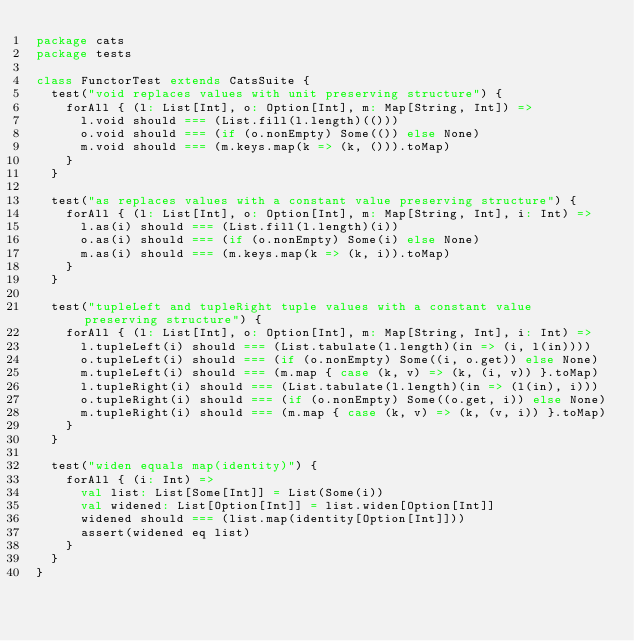Convert code to text. <code><loc_0><loc_0><loc_500><loc_500><_Scala_>package cats
package tests

class FunctorTest extends CatsSuite {
  test("void replaces values with unit preserving structure") {
    forAll { (l: List[Int], o: Option[Int], m: Map[String, Int]) =>
      l.void should === (List.fill(l.length)(()))
      o.void should === (if (o.nonEmpty) Some(()) else None)
      m.void should === (m.keys.map(k => (k, ())).toMap)
    }
  }

  test("as replaces values with a constant value preserving structure") {
    forAll { (l: List[Int], o: Option[Int], m: Map[String, Int], i: Int) =>
      l.as(i) should === (List.fill(l.length)(i))
      o.as(i) should === (if (o.nonEmpty) Some(i) else None)
      m.as(i) should === (m.keys.map(k => (k, i)).toMap)
    }
  }

  test("tupleLeft and tupleRight tuple values with a constant value preserving structure") {
    forAll { (l: List[Int], o: Option[Int], m: Map[String, Int], i: Int) =>
      l.tupleLeft(i) should === (List.tabulate(l.length)(in => (i, l(in))))
      o.tupleLeft(i) should === (if (o.nonEmpty) Some((i, o.get)) else None)
      m.tupleLeft(i) should === (m.map { case (k, v) => (k, (i, v)) }.toMap)
      l.tupleRight(i) should === (List.tabulate(l.length)(in => (l(in), i)))
      o.tupleRight(i) should === (if (o.nonEmpty) Some((o.get, i)) else None)
      m.tupleRight(i) should === (m.map { case (k, v) => (k, (v, i)) }.toMap)
    }
  }

  test("widen equals map(identity)") {
    forAll { (i: Int) =>
      val list: List[Some[Int]] = List(Some(i))
      val widened: List[Option[Int]] = list.widen[Option[Int]]
      widened should === (list.map(identity[Option[Int]]))
      assert(widened eq list)
    }
  }
}
</code> 